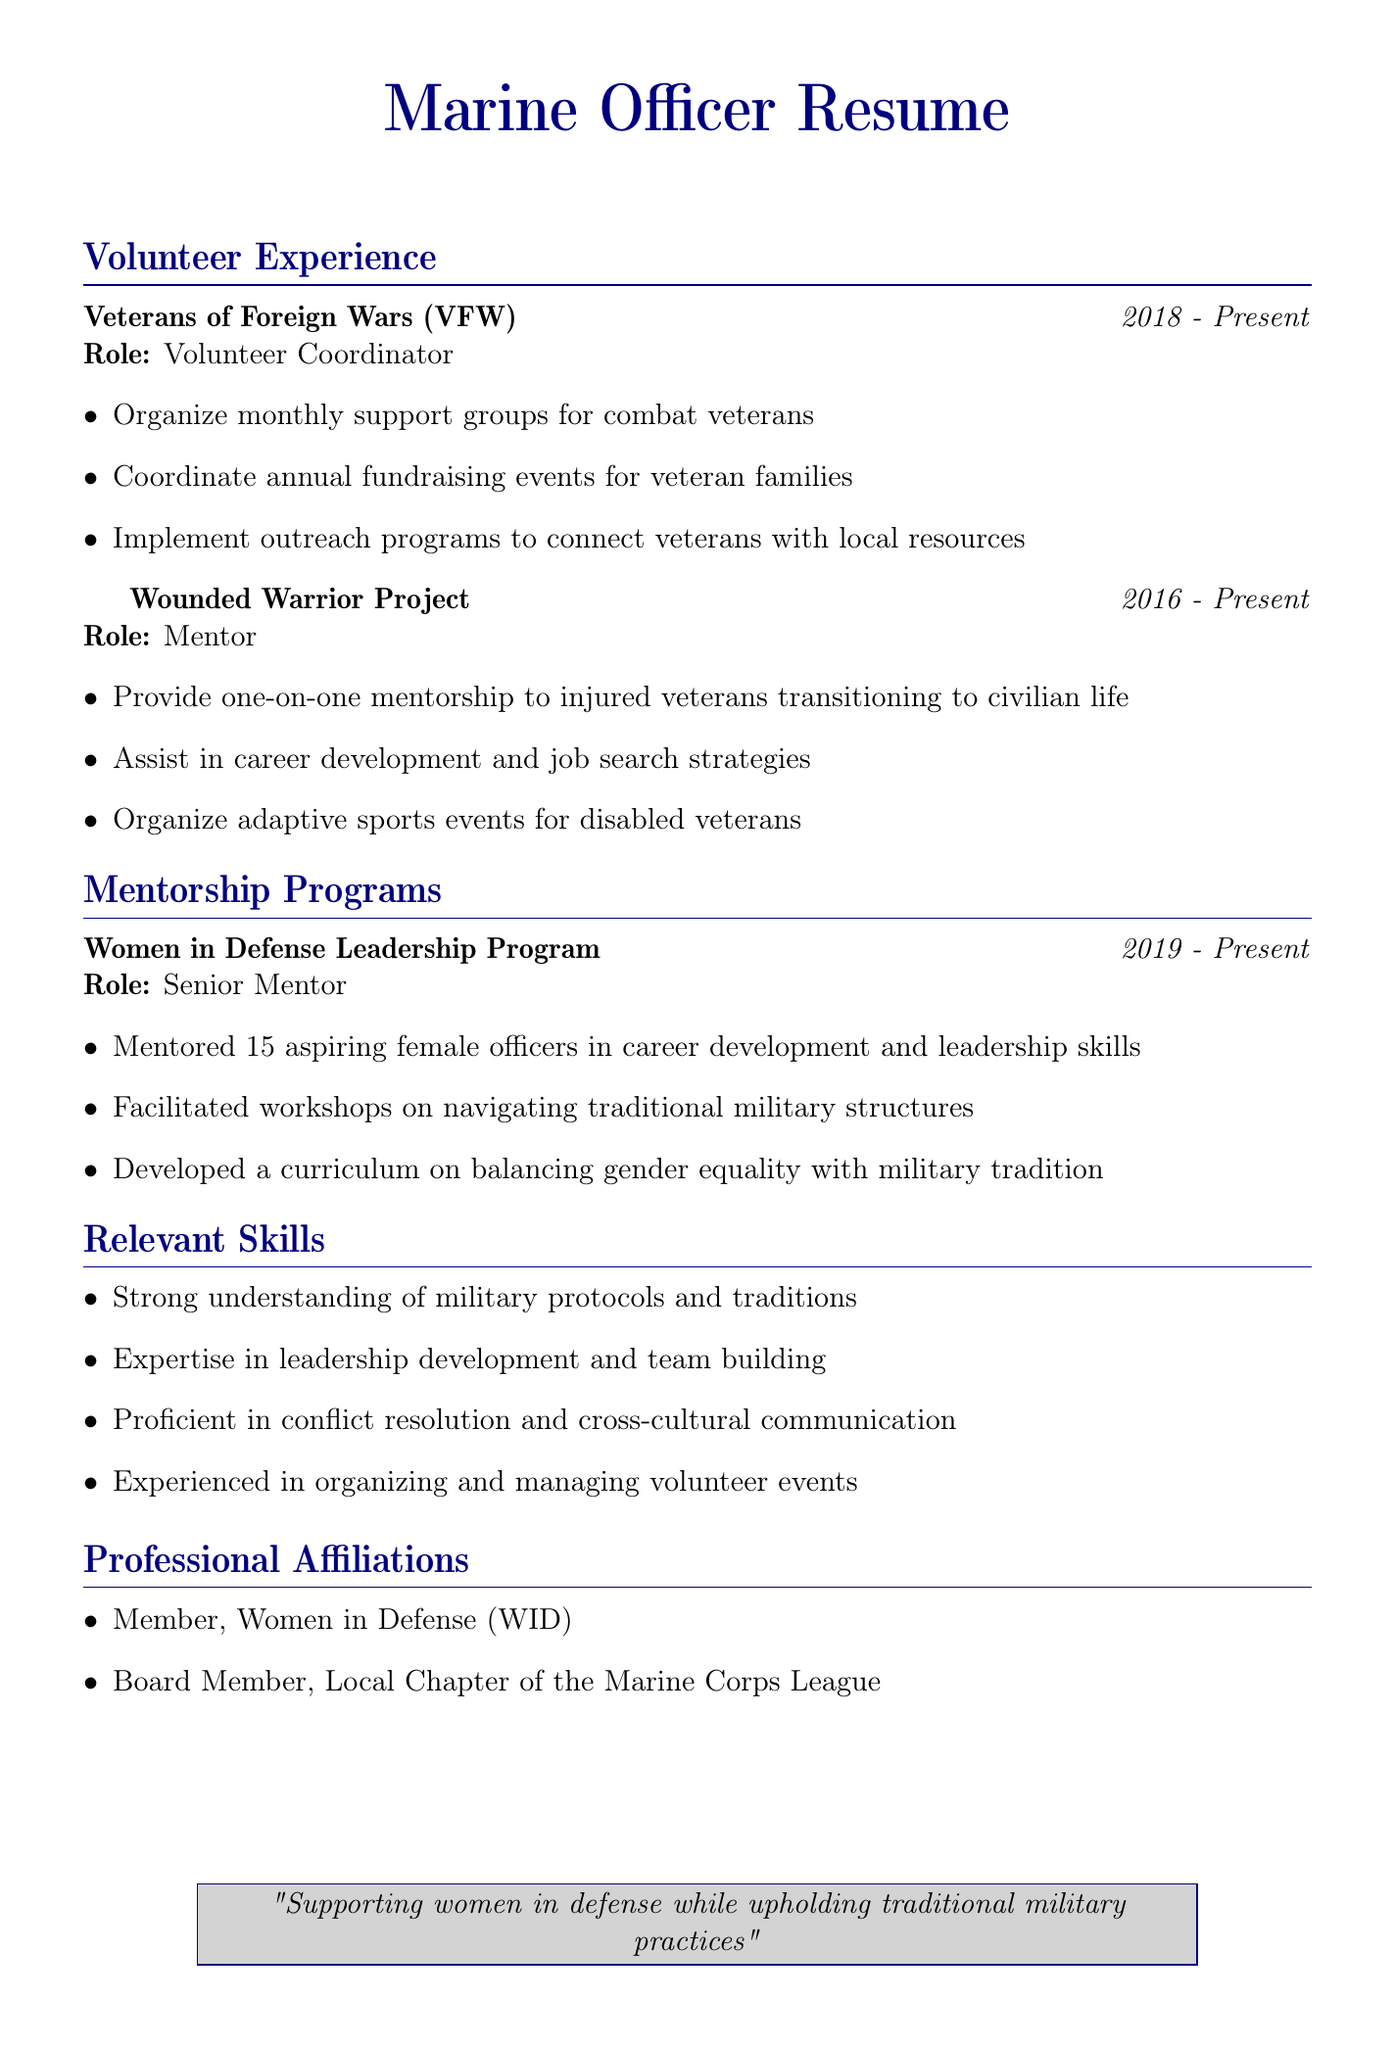What is the role at the Veterans of Foreign Wars? The role listed for the Veterans of Foreign Wars is Volunteer Coordinator.
Answer: Volunteer Coordinator In which year did the individual start volunteering with the Wounded Warrior Project? The individual began volunteering with the Wounded Warrior Project in 2016.
Answer: 2016 How many aspiring female officers were mentored in the Women in Defense Leadership Program? The document states that 15 aspiring female officers were mentored.
Answer: 15 What type of events does the individual organize for disabled veterans? The individual organizes adaptive sports events for disabled veterans.
Answer: Adaptive sports events What is one of the responsibilities of the Volunteer Coordinator at the VFW? One responsibility is to organize monthly support groups for combat veterans.
Answer: Organize monthly support groups What is the main focus of the developed curriculum in the Women in Defense Leadership Program? The curriculum focuses on balancing gender equality with military tradition.
Answer: Balancing gender equality with military tradition What is the total duration of volunteer work experience? The individual has volunteer work experience from 2016 to present, totaling 7 years.
Answer: 7 years Which organization is the individual a board member of? The individual is a board member of the Local Chapter of the Marine Corps League.
Answer: Local Chapter of the Marine Corps League 